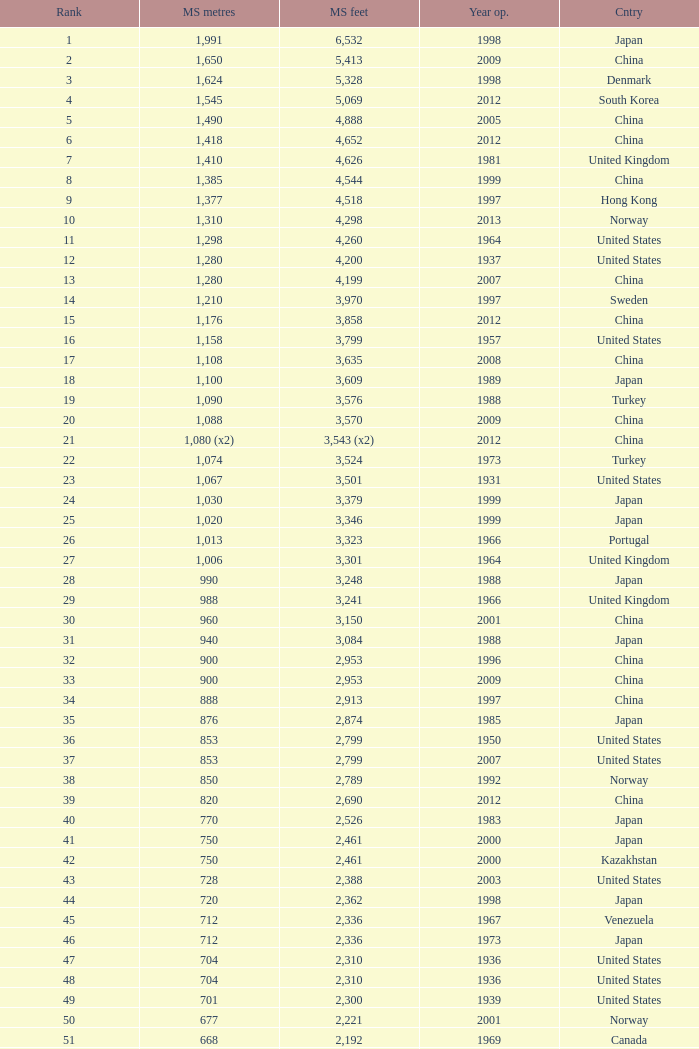In the united states, which bridge with a main span length of 421 meters, ranking above 47, and an inauguration year of 1936 has the largest main span in feet? 1381.0. 